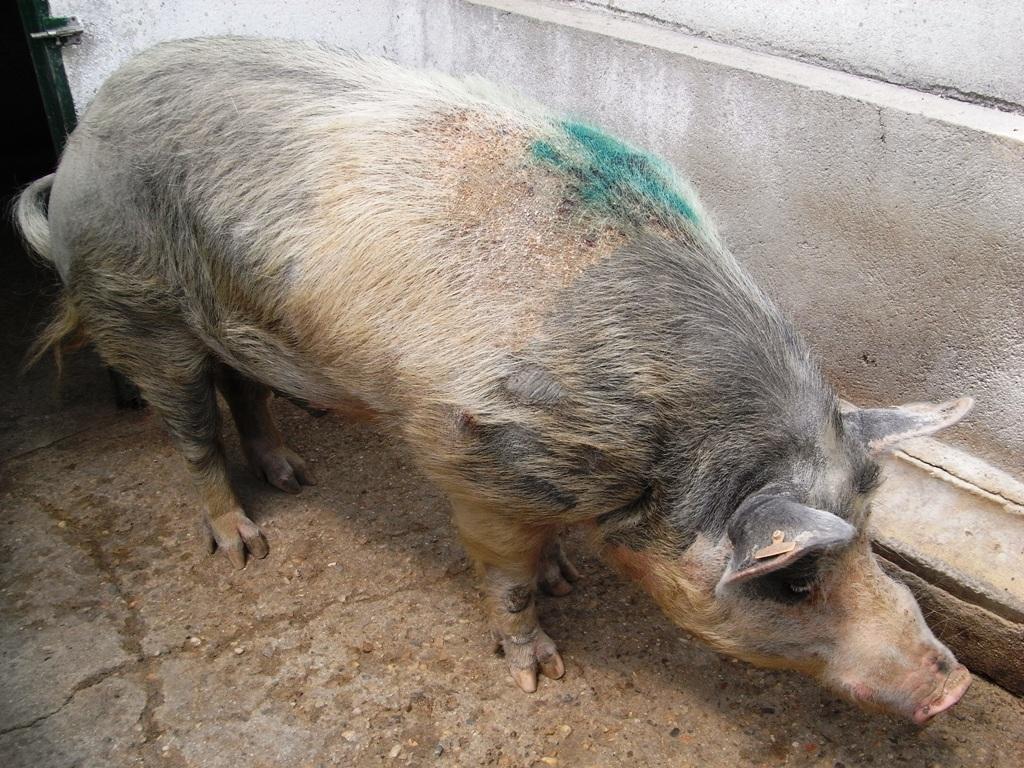Could you give a brief overview of what you see in this image? In this image I can see the pig which is in brown and black color. To the right I can see the wall. 